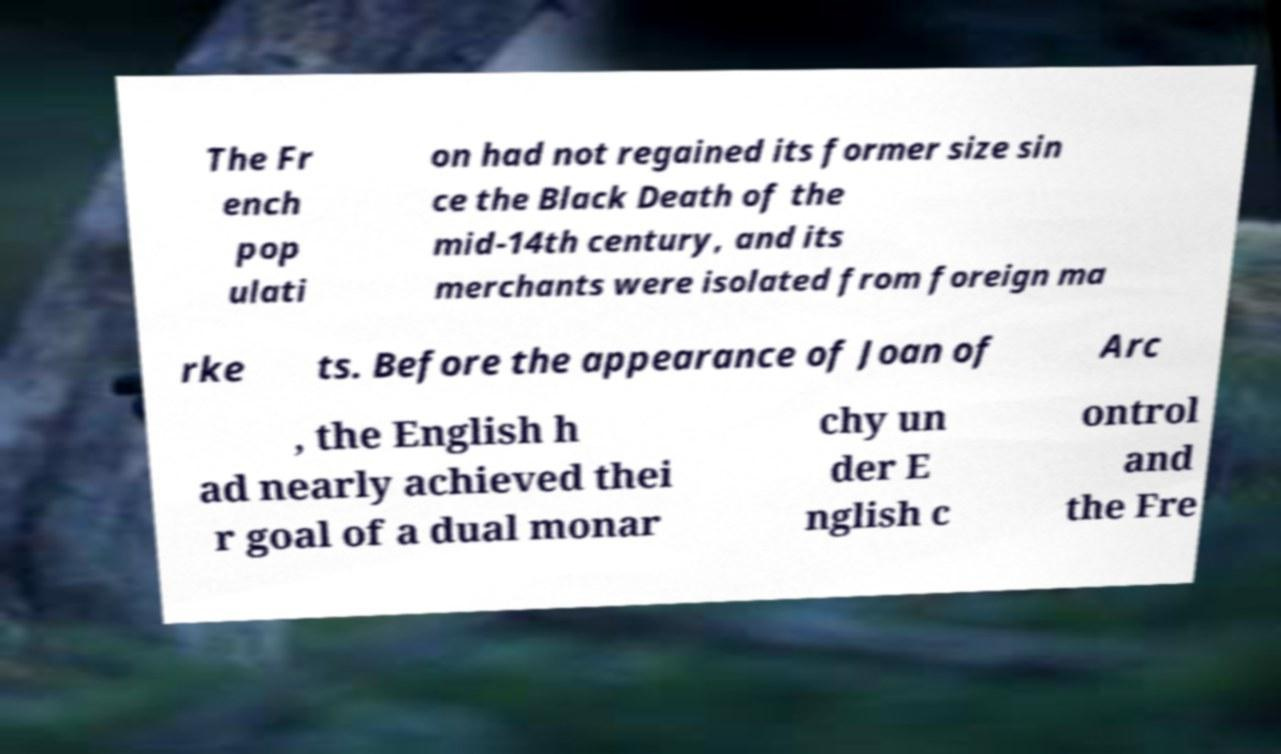Could you extract and type out the text from this image? The Fr ench pop ulati on had not regained its former size sin ce the Black Death of the mid-14th century, and its merchants were isolated from foreign ma rke ts. Before the appearance of Joan of Arc , the English h ad nearly achieved thei r goal of a dual monar chy un der E nglish c ontrol and the Fre 